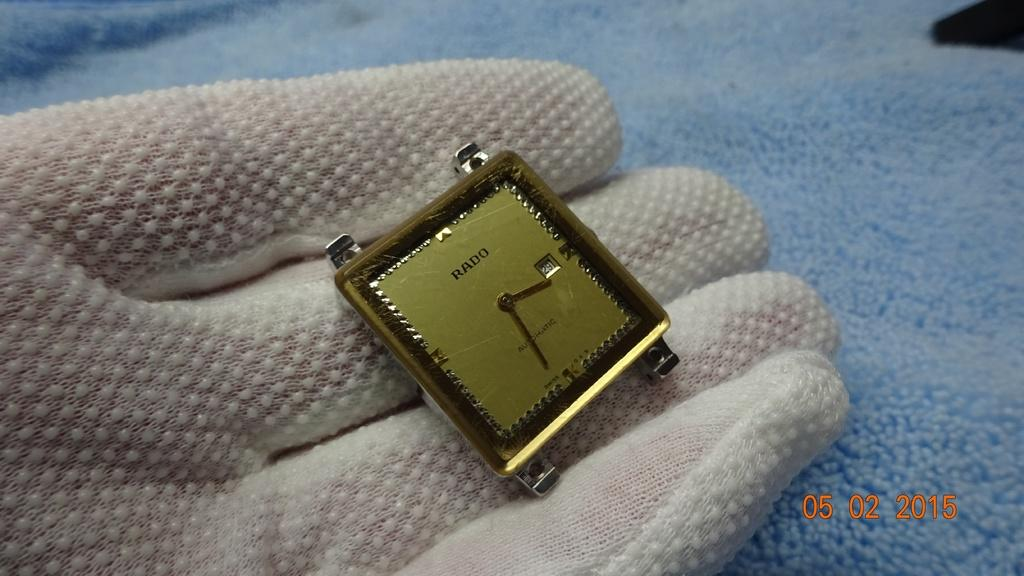<image>
Render a clear and concise summary of the photo. A Rado watch is being held by someone wearing gloves. 